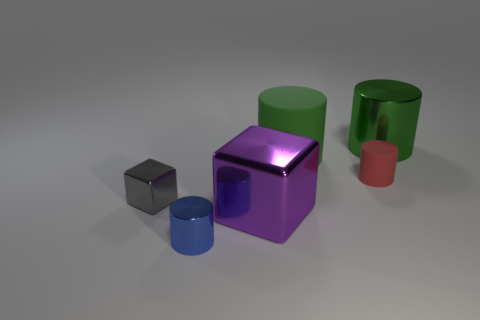What number of metal things are cylinders or gray objects?
Provide a short and direct response. 3. What size is the metal thing that is on the right side of the big metal thing left of the tiny matte object?
Provide a short and direct response. Large. What is the material of the thing that is the same color as the big shiny cylinder?
Offer a very short reply. Rubber. There is a green object in front of the shiny thing to the right of the big matte object; are there any big cylinders that are behind it?
Ensure brevity in your answer.  Yes. Does the small cylinder left of the big green matte thing have the same material as the block that is to the left of the purple thing?
Your answer should be compact. Yes. How many things are matte things or big metal objects that are in front of the tiny gray metallic object?
Your answer should be very brief. 3. What number of green things are the same shape as the red rubber thing?
Make the answer very short. 2. There is a blue cylinder that is the same size as the red rubber cylinder; what material is it?
Provide a succinct answer. Metal. What size is the shiny object that is behind the gray object to the left of the big cylinder right of the large matte object?
Your answer should be very brief. Large. There is a metal cylinder to the right of the small blue metal object; is it the same color as the rubber object that is behind the small red matte cylinder?
Offer a very short reply. Yes. 